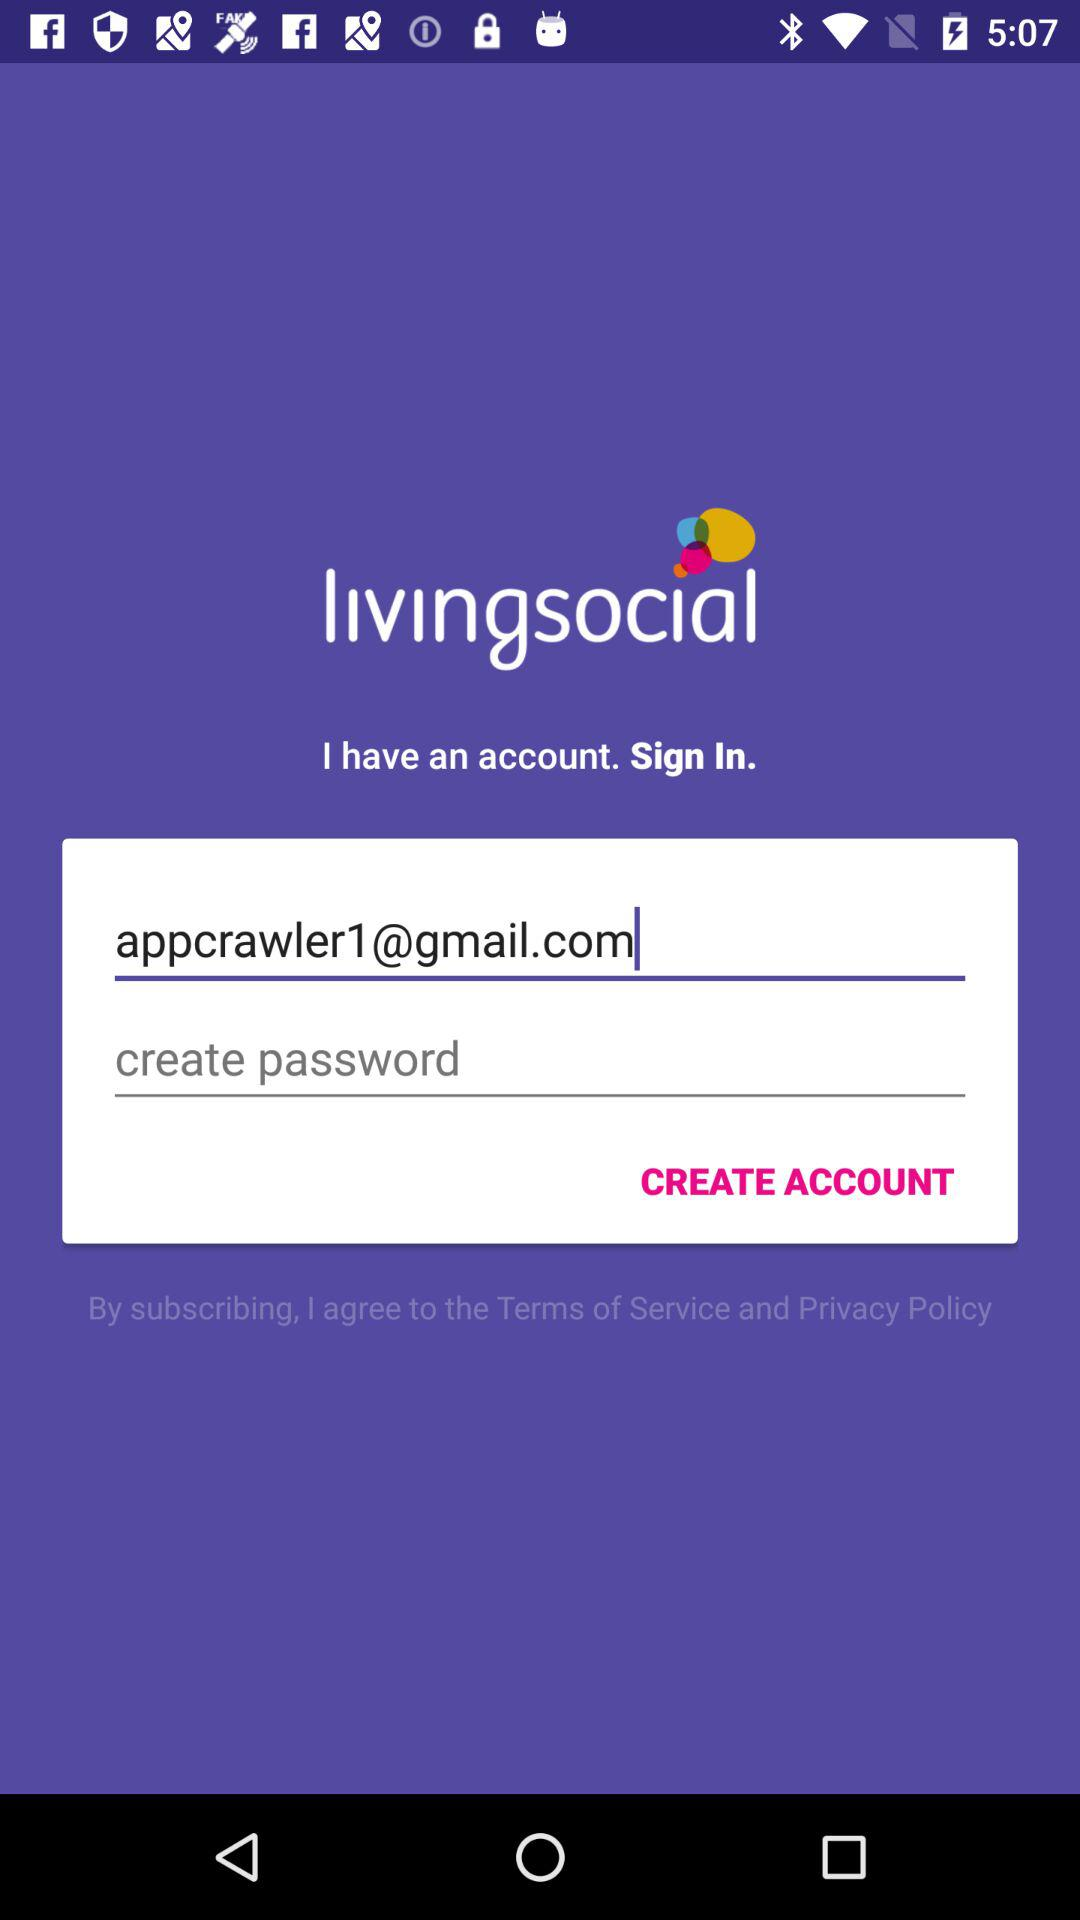What is the app name? The app name is "livingsocial". 